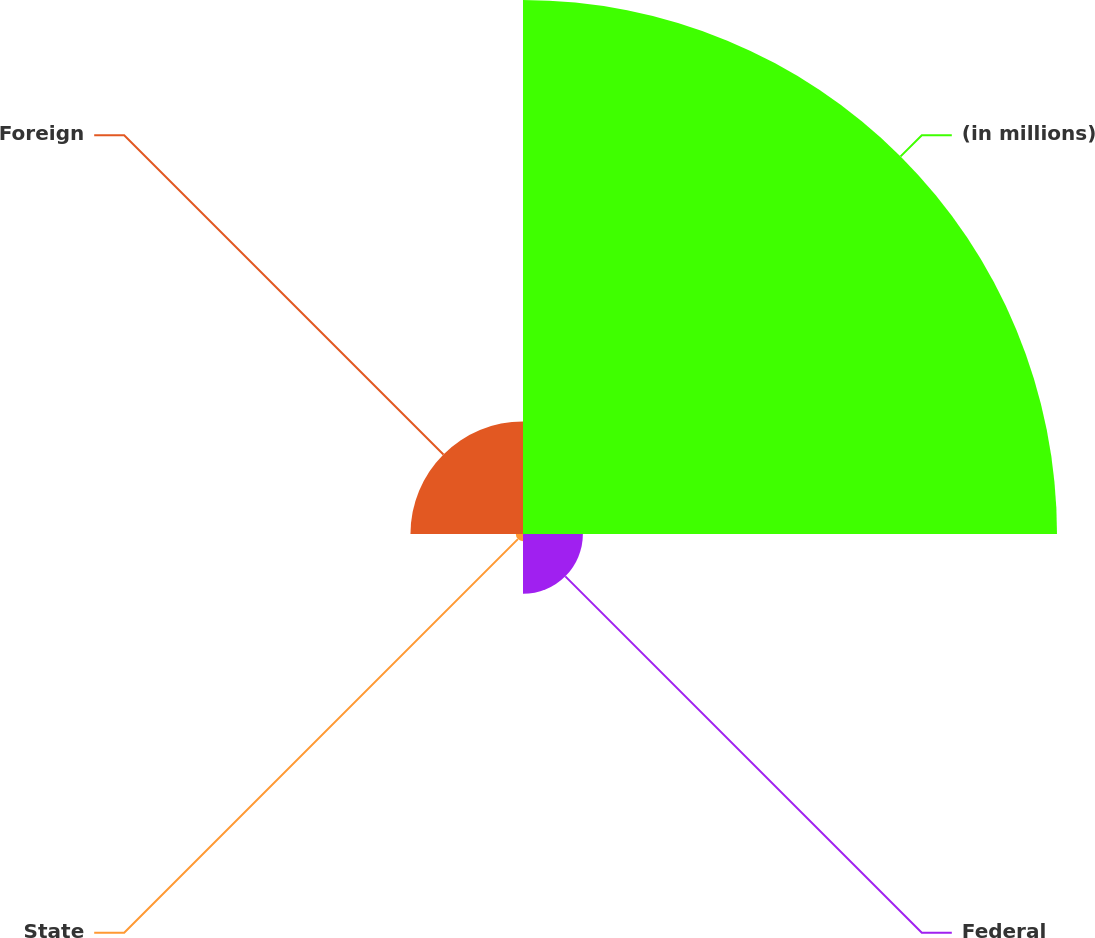<chart> <loc_0><loc_0><loc_500><loc_500><pie_chart><fcel>(in millions)<fcel>Federal<fcel>State<fcel>Foreign<nl><fcel>74.83%<fcel>8.39%<fcel>1.01%<fcel>15.77%<nl></chart> 